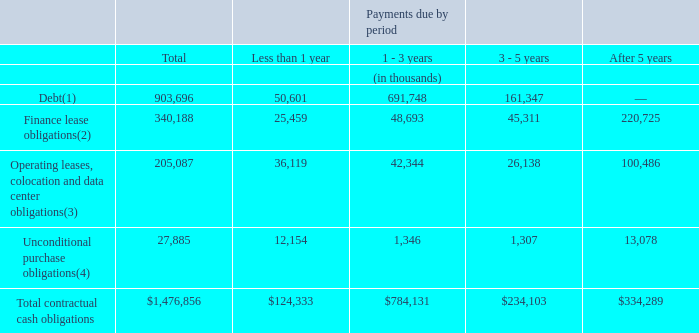Contractual Obligations and Commitments
The following table summarizes our contractual cash obligations and other commercial commitments as of December 31, 2019.
(1) These amounts include interest and principal payment obligations on our €135.0 million of 2024 Notes through the maturity date of June 30, 2024, interest and principal payments on our $445.0 million of 2022 Notes through the maturity date of March 1, 2022, interest and principal payments on our $189.2 million of 2021 Notes through the maturity date of April 15, 2021 and $12.5 million due under an installment payment agreement with a vendor.
(2) The amounts include principal and interest payments under our finance lease obligations. Our finance lease obligations were incurred in connection with IRUs for inter-city and intra-city dark fiber underlying substantial portions of our network. These finance leases are presented on our balance sheet at the net present value of the future minimum lease payments, or $169.8 million at December 31, 2019. These leases generally have initial terms of 15 to 20 years.
(3) These amounts include amounts due under our facilities, operating leases, colocation obligations and carrier neutral data center obligations. Certain of these operating lease liabilities are presented on our balance sheet at the net present value of the future minimum lease payments, or $96.8 million at December 31, 2019.
(4) These amounts include amounts due under unconditional purchase obligations including dark fiber IRU operating and finance lease agreements entered into but not delivered and accepted prior to December 31, 2019.
What is the value of the interest and principal payment obligations included in the company's debt under 2024 Notes? 135.0 million. What is the value of the interest and principal payment obligations included in the debt under 2022 Notes? 445.0 million. What is the value of the interest and principal payment obligations included in the debt under 2021 Notes? 189.2 million. What is the company's total debt due within 3 years?
Answer scale should be: thousand. (50,601 + 691,748) 
Answer: 742349. What is the company's total finance lease obligations due within 3 years?
Answer scale should be: thousand. (48,693 + 25,459) 
Answer: 74152. What is the company's unconditional purchase obligations due within 3 years?
Answer scale should be: thousand. 1,346 + 12,154 
Answer: 13500. 